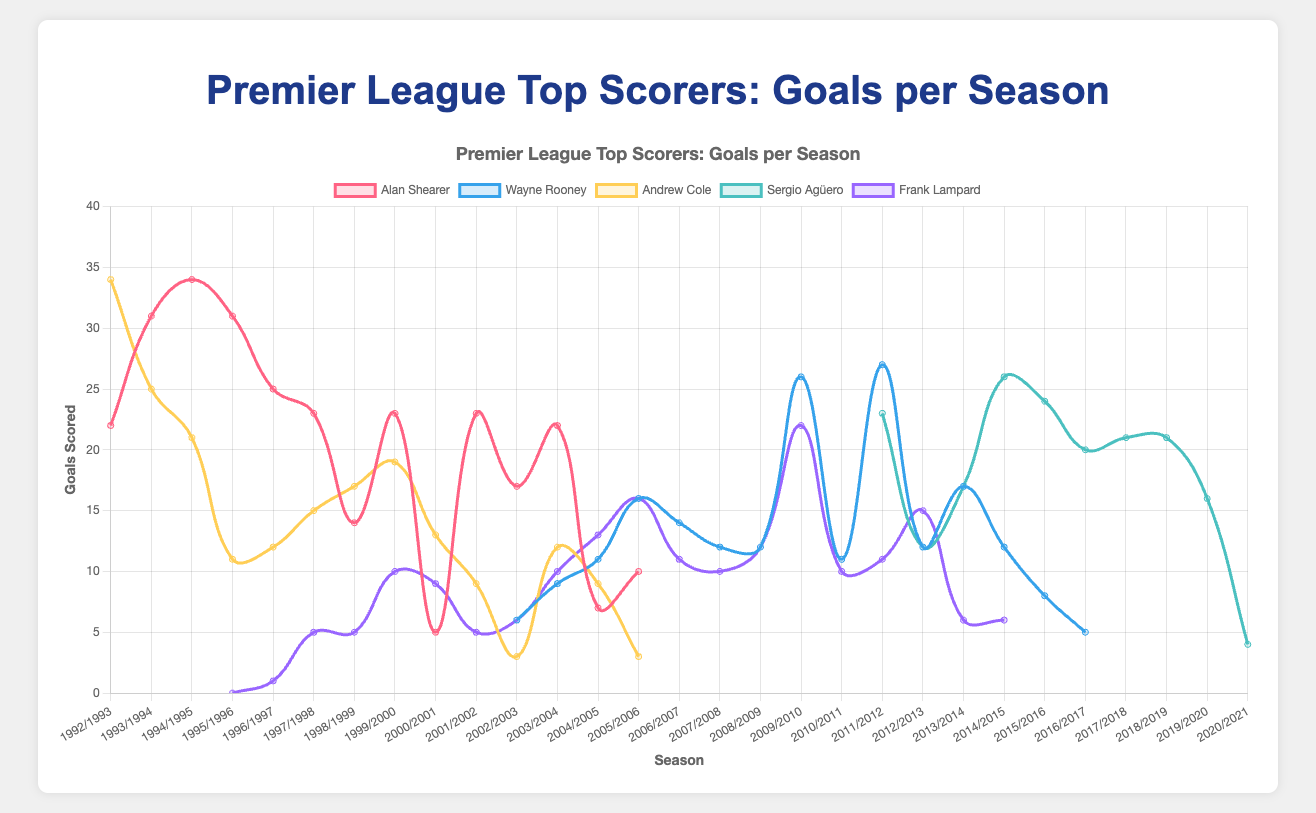Which player had the highest goals scored in a single season, and how many goals did they score? Alan Shearer in the 1994/1995 season scored the highest number of goals in a single season with 34 goals.
Answer: Alan Shearer, 34 goals Which player experienced the biggest drop in goals from one season to the next? Alan Shearer experienced the biggest drop in goals between the 1999/2000 and 2000/2001 seasons, where his goals decreased from 23 to 5, a difference of 18 goals.
Answer: Alan Shearer, 18 goals Among all players, who scored more consistently (i.e., with less variation) over their career in terms of goals per season? Frank Lampard's career shows more consistent goal-scoring compared to other players, as his goals per season are relatively steady, rarely venturing into extreme highs or lows.
Answer: Frank Lampard Which player showed the most significant improvement in goals early in their career? Comparing the early seasons, Alan Shearer's goals increased from 22 in 1992/1993 to 31 in 1993/1994, showing a significant improvement of 9 goals.
Answer: Alan Shearer Who had longer career longevity in terms of goal-scoring seasons compared to others? Alan Shearer had a career spanning from 1992/1993 to 2005/2006, giving him 14 seasons, the longest among the players.
Answer: Alan Shearer Which season showed a major peak in goals for Sergio Agüero and Wayne Rooney at the same time? Both players showed high goal counts in the 2011/2012 season with Agüero scoring 23 and Rooney scoring 27.
Answer: 2011/2012 What's the maximum number of goals Frank Lampard scored in a season? Frank Lampard scored a maximum of 22 goals in the 2009/2010 season.
Answer: 22 goals 